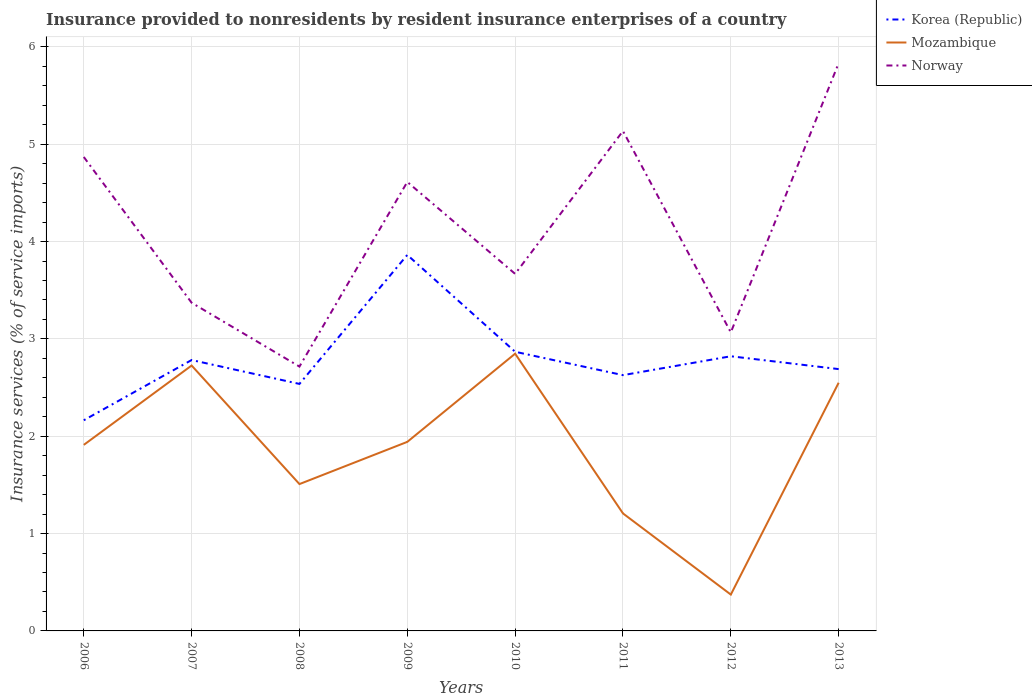How many different coloured lines are there?
Ensure brevity in your answer.  3. Is the number of lines equal to the number of legend labels?
Your response must be concise. Yes. Across all years, what is the maximum insurance provided to nonresidents in Norway?
Your answer should be compact. 2.72. In which year was the insurance provided to nonresidents in Mozambique maximum?
Offer a terse response. 2012. What is the total insurance provided to nonresidents in Mozambique in the graph?
Make the answer very short. -1.34. What is the difference between the highest and the second highest insurance provided to nonresidents in Norway?
Offer a very short reply. 3.12. What is the difference between the highest and the lowest insurance provided to nonresidents in Korea (Republic)?
Make the answer very short. 3. How many lines are there?
Offer a terse response. 3. How many years are there in the graph?
Make the answer very short. 8. What is the difference between two consecutive major ticks on the Y-axis?
Offer a terse response. 1. Does the graph contain grids?
Your answer should be compact. Yes. Where does the legend appear in the graph?
Offer a terse response. Top right. How many legend labels are there?
Your answer should be very brief. 3. How are the legend labels stacked?
Ensure brevity in your answer.  Vertical. What is the title of the graph?
Make the answer very short. Insurance provided to nonresidents by resident insurance enterprises of a country. What is the label or title of the X-axis?
Ensure brevity in your answer.  Years. What is the label or title of the Y-axis?
Offer a terse response. Insurance services (% of service imports). What is the Insurance services (% of service imports) in Korea (Republic) in 2006?
Provide a short and direct response. 2.16. What is the Insurance services (% of service imports) of Mozambique in 2006?
Keep it short and to the point. 1.91. What is the Insurance services (% of service imports) in Norway in 2006?
Offer a very short reply. 4.87. What is the Insurance services (% of service imports) in Korea (Republic) in 2007?
Provide a succinct answer. 2.78. What is the Insurance services (% of service imports) of Mozambique in 2007?
Ensure brevity in your answer.  2.73. What is the Insurance services (% of service imports) of Norway in 2007?
Keep it short and to the point. 3.37. What is the Insurance services (% of service imports) in Korea (Republic) in 2008?
Offer a very short reply. 2.54. What is the Insurance services (% of service imports) in Mozambique in 2008?
Offer a very short reply. 1.51. What is the Insurance services (% of service imports) of Norway in 2008?
Give a very brief answer. 2.72. What is the Insurance services (% of service imports) of Korea (Republic) in 2009?
Your answer should be very brief. 3.86. What is the Insurance services (% of service imports) of Mozambique in 2009?
Make the answer very short. 1.94. What is the Insurance services (% of service imports) of Norway in 2009?
Your response must be concise. 4.61. What is the Insurance services (% of service imports) of Korea (Republic) in 2010?
Your response must be concise. 2.87. What is the Insurance services (% of service imports) in Mozambique in 2010?
Provide a short and direct response. 2.85. What is the Insurance services (% of service imports) in Norway in 2010?
Give a very brief answer. 3.67. What is the Insurance services (% of service imports) of Korea (Republic) in 2011?
Make the answer very short. 2.63. What is the Insurance services (% of service imports) of Mozambique in 2011?
Provide a short and direct response. 1.21. What is the Insurance services (% of service imports) of Norway in 2011?
Provide a succinct answer. 5.14. What is the Insurance services (% of service imports) of Korea (Republic) in 2012?
Provide a short and direct response. 2.82. What is the Insurance services (% of service imports) in Mozambique in 2012?
Ensure brevity in your answer.  0.37. What is the Insurance services (% of service imports) of Norway in 2012?
Give a very brief answer. 3.07. What is the Insurance services (% of service imports) of Korea (Republic) in 2013?
Your answer should be compact. 2.69. What is the Insurance services (% of service imports) of Mozambique in 2013?
Give a very brief answer. 2.55. What is the Insurance services (% of service imports) in Norway in 2013?
Ensure brevity in your answer.  5.83. Across all years, what is the maximum Insurance services (% of service imports) of Korea (Republic)?
Your response must be concise. 3.86. Across all years, what is the maximum Insurance services (% of service imports) of Mozambique?
Offer a very short reply. 2.85. Across all years, what is the maximum Insurance services (% of service imports) in Norway?
Provide a short and direct response. 5.83. Across all years, what is the minimum Insurance services (% of service imports) in Korea (Republic)?
Ensure brevity in your answer.  2.16. Across all years, what is the minimum Insurance services (% of service imports) in Mozambique?
Provide a succinct answer. 0.37. Across all years, what is the minimum Insurance services (% of service imports) of Norway?
Offer a terse response. 2.72. What is the total Insurance services (% of service imports) of Korea (Republic) in the graph?
Keep it short and to the point. 22.35. What is the total Insurance services (% of service imports) in Mozambique in the graph?
Provide a succinct answer. 15.07. What is the total Insurance services (% of service imports) in Norway in the graph?
Your response must be concise. 33.27. What is the difference between the Insurance services (% of service imports) of Korea (Republic) in 2006 and that in 2007?
Your response must be concise. -0.62. What is the difference between the Insurance services (% of service imports) in Mozambique in 2006 and that in 2007?
Give a very brief answer. -0.82. What is the difference between the Insurance services (% of service imports) in Norway in 2006 and that in 2007?
Keep it short and to the point. 1.5. What is the difference between the Insurance services (% of service imports) in Korea (Republic) in 2006 and that in 2008?
Offer a very short reply. -0.37. What is the difference between the Insurance services (% of service imports) of Mozambique in 2006 and that in 2008?
Make the answer very short. 0.4. What is the difference between the Insurance services (% of service imports) of Norway in 2006 and that in 2008?
Give a very brief answer. 2.15. What is the difference between the Insurance services (% of service imports) of Korea (Republic) in 2006 and that in 2009?
Offer a terse response. -1.7. What is the difference between the Insurance services (% of service imports) in Mozambique in 2006 and that in 2009?
Offer a very short reply. -0.03. What is the difference between the Insurance services (% of service imports) of Norway in 2006 and that in 2009?
Your answer should be compact. 0.26. What is the difference between the Insurance services (% of service imports) in Korea (Republic) in 2006 and that in 2010?
Make the answer very short. -0.7. What is the difference between the Insurance services (% of service imports) in Mozambique in 2006 and that in 2010?
Offer a very short reply. -0.94. What is the difference between the Insurance services (% of service imports) of Norway in 2006 and that in 2010?
Keep it short and to the point. 1.2. What is the difference between the Insurance services (% of service imports) of Korea (Republic) in 2006 and that in 2011?
Your answer should be very brief. -0.46. What is the difference between the Insurance services (% of service imports) in Mozambique in 2006 and that in 2011?
Your response must be concise. 0.7. What is the difference between the Insurance services (% of service imports) of Norway in 2006 and that in 2011?
Your response must be concise. -0.27. What is the difference between the Insurance services (% of service imports) of Korea (Republic) in 2006 and that in 2012?
Your answer should be compact. -0.66. What is the difference between the Insurance services (% of service imports) in Mozambique in 2006 and that in 2012?
Provide a succinct answer. 1.54. What is the difference between the Insurance services (% of service imports) of Norway in 2006 and that in 2012?
Make the answer very short. 1.8. What is the difference between the Insurance services (% of service imports) in Korea (Republic) in 2006 and that in 2013?
Offer a terse response. -0.53. What is the difference between the Insurance services (% of service imports) in Mozambique in 2006 and that in 2013?
Your response must be concise. -0.64. What is the difference between the Insurance services (% of service imports) in Norway in 2006 and that in 2013?
Your answer should be compact. -0.96. What is the difference between the Insurance services (% of service imports) in Korea (Republic) in 2007 and that in 2008?
Offer a very short reply. 0.25. What is the difference between the Insurance services (% of service imports) of Mozambique in 2007 and that in 2008?
Your response must be concise. 1.22. What is the difference between the Insurance services (% of service imports) in Norway in 2007 and that in 2008?
Offer a terse response. 0.66. What is the difference between the Insurance services (% of service imports) in Korea (Republic) in 2007 and that in 2009?
Keep it short and to the point. -1.08. What is the difference between the Insurance services (% of service imports) in Mozambique in 2007 and that in 2009?
Keep it short and to the point. 0.78. What is the difference between the Insurance services (% of service imports) in Norway in 2007 and that in 2009?
Offer a terse response. -1.24. What is the difference between the Insurance services (% of service imports) in Korea (Republic) in 2007 and that in 2010?
Your answer should be compact. -0.09. What is the difference between the Insurance services (% of service imports) in Mozambique in 2007 and that in 2010?
Give a very brief answer. -0.12. What is the difference between the Insurance services (% of service imports) in Norway in 2007 and that in 2010?
Keep it short and to the point. -0.3. What is the difference between the Insurance services (% of service imports) of Korea (Republic) in 2007 and that in 2011?
Keep it short and to the point. 0.16. What is the difference between the Insurance services (% of service imports) of Mozambique in 2007 and that in 2011?
Keep it short and to the point. 1.52. What is the difference between the Insurance services (% of service imports) of Norway in 2007 and that in 2011?
Give a very brief answer. -1.76. What is the difference between the Insurance services (% of service imports) of Korea (Republic) in 2007 and that in 2012?
Ensure brevity in your answer.  -0.04. What is the difference between the Insurance services (% of service imports) of Mozambique in 2007 and that in 2012?
Offer a very short reply. 2.35. What is the difference between the Insurance services (% of service imports) in Norway in 2007 and that in 2012?
Make the answer very short. 0.3. What is the difference between the Insurance services (% of service imports) of Korea (Republic) in 2007 and that in 2013?
Keep it short and to the point. 0.09. What is the difference between the Insurance services (% of service imports) in Mozambique in 2007 and that in 2013?
Make the answer very short. 0.18. What is the difference between the Insurance services (% of service imports) in Norway in 2007 and that in 2013?
Your answer should be very brief. -2.46. What is the difference between the Insurance services (% of service imports) in Korea (Republic) in 2008 and that in 2009?
Offer a terse response. -1.33. What is the difference between the Insurance services (% of service imports) of Mozambique in 2008 and that in 2009?
Offer a very short reply. -0.43. What is the difference between the Insurance services (% of service imports) of Norway in 2008 and that in 2009?
Provide a succinct answer. -1.9. What is the difference between the Insurance services (% of service imports) in Korea (Republic) in 2008 and that in 2010?
Ensure brevity in your answer.  -0.33. What is the difference between the Insurance services (% of service imports) of Mozambique in 2008 and that in 2010?
Provide a short and direct response. -1.34. What is the difference between the Insurance services (% of service imports) in Norway in 2008 and that in 2010?
Offer a terse response. -0.95. What is the difference between the Insurance services (% of service imports) in Korea (Republic) in 2008 and that in 2011?
Ensure brevity in your answer.  -0.09. What is the difference between the Insurance services (% of service imports) in Mozambique in 2008 and that in 2011?
Offer a very short reply. 0.3. What is the difference between the Insurance services (% of service imports) of Norway in 2008 and that in 2011?
Your response must be concise. -2.42. What is the difference between the Insurance services (% of service imports) in Korea (Republic) in 2008 and that in 2012?
Your answer should be very brief. -0.28. What is the difference between the Insurance services (% of service imports) in Mozambique in 2008 and that in 2012?
Offer a very short reply. 1.14. What is the difference between the Insurance services (% of service imports) in Norway in 2008 and that in 2012?
Your answer should be compact. -0.35. What is the difference between the Insurance services (% of service imports) of Korea (Republic) in 2008 and that in 2013?
Provide a succinct answer. -0.15. What is the difference between the Insurance services (% of service imports) of Mozambique in 2008 and that in 2013?
Make the answer very short. -1.04. What is the difference between the Insurance services (% of service imports) in Norway in 2008 and that in 2013?
Your answer should be compact. -3.12. What is the difference between the Insurance services (% of service imports) in Mozambique in 2009 and that in 2010?
Give a very brief answer. -0.91. What is the difference between the Insurance services (% of service imports) of Norway in 2009 and that in 2010?
Offer a terse response. 0.94. What is the difference between the Insurance services (% of service imports) in Korea (Republic) in 2009 and that in 2011?
Make the answer very short. 1.24. What is the difference between the Insurance services (% of service imports) in Mozambique in 2009 and that in 2011?
Ensure brevity in your answer.  0.74. What is the difference between the Insurance services (% of service imports) in Norway in 2009 and that in 2011?
Provide a succinct answer. -0.52. What is the difference between the Insurance services (% of service imports) of Korea (Republic) in 2009 and that in 2012?
Ensure brevity in your answer.  1.04. What is the difference between the Insurance services (% of service imports) in Mozambique in 2009 and that in 2012?
Give a very brief answer. 1.57. What is the difference between the Insurance services (% of service imports) in Norway in 2009 and that in 2012?
Provide a succinct answer. 1.55. What is the difference between the Insurance services (% of service imports) of Korea (Republic) in 2009 and that in 2013?
Keep it short and to the point. 1.17. What is the difference between the Insurance services (% of service imports) in Mozambique in 2009 and that in 2013?
Provide a short and direct response. -0.61. What is the difference between the Insurance services (% of service imports) in Norway in 2009 and that in 2013?
Ensure brevity in your answer.  -1.22. What is the difference between the Insurance services (% of service imports) in Korea (Republic) in 2010 and that in 2011?
Provide a succinct answer. 0.24. What is the difference between the Insurance services (% of service imports) of Mozambique in 2010 and that in 2011?
Offer a terse response. 1.64. What is the difference between the Insurance services (% of service imports) of Norway in 2010 and that in 2011?
Offer a terse response. -1.47. What is the difference between the Insurance services (% of service imports) of Korea (Republic) in 2010 and that in 2012?
Keep it short and to the point. 0.05. What is the difference between the Insurance services (% of service imports) in Mozambique in 2010 and that in 2012?
Keep it short and to the point. 2.47. What is the difference between the Insurance services (% of service imports) of Norway in 2010 and that in 2012?
Your answer should be compact. 0.6. What is the difference between the Insurance services (% of service imports) of Korea (Republic) in 2010 and that in 2013?
Provide a succinct answer. 0.18. What is the difference between the Insurance services (% of service imports) of Mozambique in 2010 and that in 2013?
Keep it short and to the point. 0.3. What is the difference between the Insurance services (% of service imports) of Norway in 2010 and that in 2013?
Provide a short and direct response. -2.16. What is the difference between the Insurance services (% of service imports) of Korea (Republic) in 2011 and that in 2012?
Your answer should be very brief. -0.19. What is the difference between the Insurance services (% of service imports) of Mozambique in 2011 and that in 2012?
Your response must be concise. 0.83. What is the difference between the Insurance services (% of service imports) in Norway in 2011 and that in 2012?
Provide a succinct answer. 2.07. What is the difference between the Insurance services (% of service imports) in Korea (Republic) in 2011 and that in 2013?
Your answer should be very brief. -0.06. What is the difference between the Insurance services (% of service imports) in Mozambique in 2011 and that in 2013?
Offer a very short reply. -1.34. What is the difference between the Insurance services (% of service imports) in Norway in 2011 and that in 2013?
Offer a very short reply. -0.7. What is the difference between the Insurance services (% of service imports) in Korea (Republic) in 2012 and that in 2013?
Provide a succinct answer. 0.13. What is the difference between the Insurance services (% of service imports) of Mozambique in 2012 and that in 2013?
Ensure brevity in your answer.  -2.18. What is the difference between the Insurance services (% of service imports) in Norway in 2012 and that in 2013?
Make the answer very short. -2.77. What is the difference between the Insurance services (% of service imports) in Korea (Republic) in 2006 and the Insurance services (% of service imports) in Mozambique in 2007?
Offer a very short reply. -0.56. What is the difference between the Insurance services (% of service imports) in Korea (Republic) in 2006 and the Insurance services (% of service imports) in Norway in 2007?
Make the answer very short. -1.21. What is the difference between the Insurance services (% of service imports) of Mozambique in 2006 and the Insurance services (% of service imports) of Norway in 2007?
Ensure brevity in your answer.  -1.46. What is the difference between the Insurance services (% of service imports) of Korea (Republic) in 2006 and the Insurance services (% of service imports) of Mozambique in 2008?
Give a very brief answer. 0.66. What is the difference between the Insurance services (% of service imports) of Korea (Republic) in 2006 and the Insurance services (% of service imports) of Norway in 2008?
Provide a short and direct response. -0.55. What is the difference between the Insurance services (% of service imports) of Mozambique in 2006 and the Insurance services (% of service imports) of Norway in 2008?
Keep it short and to the point. -0.8. What is the difference between the Insurance services (% of service imports) in Korea (Republic) in 2006 and the Insurance services (% of service imports) in Mozambique in 2009?
Your answer should be compact. 0.22. What is the difference between the Insurance services (% of service imports) of Korea (Republic) in 2006 and the Insurance services (% of service imports) of Norway in 2009?
Your answer should be compact. -2.45. What is the difference between the Insurance services (% of service imports) in Mozambique in 2006 and the Insurance services (% of service imports) in Norway in 2009?
Keep it short and to the point. -2.7. What is the difference between the Insurance services (% of service imports) of Korea (Republic) in 2006 and the Insurance services (% of service imports) of Mozambique in 2010?
Your answer should be compact. -0.68. What is the difference between the Insurance services (% of service imports) of Korea (Republic) in 2006 and the Insurance services (% of service imports) of Norway in 2010?
Your answer should be compact. -1.5. What is the difference between the Insurance services (% of service imports) in Mozambique in 2006 and the Insurance services (% of service imports) in Norway in 2010?
Your answer should be compact. -1.76. What is the difference between the Insurance services (% of service imports) in Korea (Republic) in 2006 and the Insurance services (% of service imports) in Norway in 2011?
Offer a terse response. -2.97. What is the difference between the Insurance services (% of service imports) of Mozambique in 2006 and the Insurance services (% of service imports) of Norway in 2011?
Offer a terse response. -3.22. What is the difference between the Insurance services (% of service imports) in Korea (Republic) in 2006 and the Insurance services (% of service imports) in Mozambique in 2012?
Provide a succinct answer. 1.79. What is the difference between the Insurance services (% of service imports) of Korea (Republic) in 2006 and the Insurance services (% of service imports) of Norway in 2012?
Your answer should be very brief. -0.9. What is the difference between the Insurance services (% of service imports) in Mozambique in 2006 and the Insurance services (% of service imports) in Norway in 2012?
Offer a terse response. -1.16. What is the difference between the Insurance services (% of service imports) in Korea (Republic) in 2006 and the Insurance services (% of service imports) in Mozambique in 2013?
Keep it short and to the point. -0.39. What is the difference between the Insurance services (% of service imports) of Korea (Republic) in 2006 and the Insurance services (% of service imports) of Norway in 2013?
Give a very brief answer. -3.67. What is the difference between the Insurance services (% of service imports) in Mozambique in 2006 and the Insurance services (% of service imports) in Norway in 2013?
Your answer should be compact. -3.92. What is the difference between the Insurance services (% of service imports) in Korea (Republic) in 2007 and the Insurance services (% of service imports) in Mozambique in 2008?
Your answer should be very brief. 1.27. What is the difference between the Insurance services (% of service imports) in Korea (Republic) in 2007 and the Insurance services (% of service imports) in Norway in 2008?
Provide a succinct answer. 0.07. What is the difference between the Insurance services (% of service imports) of Mozambique in 2007 and the Insurance services (% of service imports) of Norway in 2008?
Offer a terse response. 0.01. What is the difference between the Insurance services (% of service imports) in Korea (Republic) in 2007 and the Insurance services (% of service imports) in Mozambique in 2009?
Give a very brief answer. 0.84. What is the difference between the Insurance services (% of service imports) of Korea (Republic) in 2007 and the Insurance services (% of service imports) of Norway in 2009?
Ensure brevity in your answer.  -1.83. What is the difference between the Insurance services (% of service imports) of Mozambique in 2007 and the Insurance services (% of service imports) of Norway in 2009?
Your response must be concise. -1.89. What is the difference between the Insurance services (% of service imports) of Korea (Republic) in 2007 and the Insurance services (% of service imports) of Mozambique in 2010?
Ensure brevity in your answer.  -0.07. What is the difference between the Insurance services (% of service imports) in Korea (Republic) in 2007 and the Insurance services (% of service imports) in Norway in 2010?
Your answer should be compact. -0.89. What is the difference between the Insurance services (% of service imports) in Mozambique in 2007 and the Insurance services (% of service imports) in Norway in 2010?
Provide a succinct answer. -0.94. What is the difference between the Insurance services (% of service imports) of Korea (Republic) in 2007 and the Insurance services (% of service imports) of Mozambique in 2011?
Provide a short and direct response. 1.58. What is the difference between the Insurance services (% of service imports) of Korea (Republic) in 2007 and the Insurance services (% of service imports) of Norway in 2011?
Provide a succinct answer. -2.35. What is the difference between the Insurance services (% of service imports) of Mozambique in 2007 and the Insurance services (% of service imports) of Norway in 2011?
Offer a very short reply. -2.41. What is the difference between the Insurance services (% of service imports) of Korea (Republic) in 2007 and the Insurance services (% of service imports) of Mozambique in 2012?
Give a very brief answer. 2.41. What is the difference between the Insurance services (% of service imports) of Korea (Republic) in 2007 and the Insurance services (% of service imports) of Norway in 2012?
Your answer should be compact. -0.28. What is the difference between the Insurance services (% of service imports) in Mozambique in 2007 and the Insurance services (% of service imports) in Norway in 2012?
Make the answer very short. -0.34. What is the difference between the Insurance services (% of service imports) of Korea (Republic) in 2007 and the Insurance services (% of service imports) of Mozambique in 2013?
Offer a very short reply. 0.23. What is the difference between the Insurance services (% of service imports) in Korea (Republic) in 2007 and the Insurance services (% of service imports) in Norway in 2013?
Provide a short and direct response. -3.05. What is the difference between the Insurance services (% of service imports) of Mozambique in 2007 and the Insurance services (% of service imports) of Norway in 2013?
Ensure brevity in your answer.  -3.11. What is the difference between the Insurance services (% of service imports) of Korea (Republic) in 2008 and the Insurance services (% of service imports) of Mozambique in 2009?
Provide a short and direct response. 0.6. What is the difference between the Insurance services (% of service imports) in Korea (Republic) in 2008 and the Insurance services (% of service imports) in Norway in 2009?
Provide a short and direct response. -2.07. What is the difference between the Insurance services (% of service imports) of Mozambique in 2008 and the Insurance services (% of service imports) of Norway in 2009?
Your answer should be compact. -3.1. What is the difference between the Insurance services (% of service imports) in Korea (Republic) in 2008 and the Insurance services (% of service imports) in Mozambique in 2010?
Give a very brief answer. -0.31. What is the difference between the Insurance services (% of service imports) in Korea (Republic) in 2008 and the Insurance services (% of service imports) in Norway in 2010?
Provide a short and direct response. -1.13. What is the difference between the Insurance services (% of service imports) of Mozambique in 2008 and the Insurance services (% of service imports) of Norway in 2010?
Give a very brief answer. -2.16. What is the difference between the Insurance services (% of service imports) in Korea (Republic) in 2008 and the Insurance services (% of service imports) in Mozambique in 2011?
Provide a short and direct response. 1.33. What is the difference between the Insurance services (% of service imports) of Korea (Republic) in 2008 and the Insurance services (% of service imports) of Norway in 2011?
Offer a very short reply. -2.6. What is the difference between the Insurance services (% of service imports) in Mozambique in 2008 and the Insurance services (% of service imports) in Norway in 2011?
Your answer should be compact. -3.63. What is the difference between the Insurance services (% of service imports) in Korea (Republic) in 2008 and the Insurance services (% of service imports) in Mozambique in 2012?
Keep it short and to the point. 2.16. What is the difference between the Insurance services (% of service imports) of Korea (Republic) in 2008 and the Insurance services (% of service imports) of Norway in 2012?
Give a very brief answer. -0.53. What is the difference between the Insurance services (% of service imports) of Mozambique in 2008 and the Insurance services (% of service imports) of Norway in 2012?
Give a very brief answer. -1.56. What is the difference between the Insurance services (% of service imports) in Korea (Republic) in 2008 and the Insurance services (% of service imports) in Mozambique in 2013?
Offer a terse response. -0.01. What is the difference between the Insurance services (% of service imports) in Korea (Republic) in 2008 and the Insurance services (% of service imports) in Norway in 2013?
Give a very brief answer. -3.3. What is the difference between the Insurance services (% of service imports) in Mozambique in 2008 and the Insurance services (% of service imports) in Norway in 2013?
Provide a short and direct response. -4.32. What is the difference between the Insurance services (% of service imports) in Korea (Republic) in 2009 and the Insurance services (% of service imports) in Mozambique in 2010?
Make the answer very short. 1.01. What is the difference between the Insurance services (% of service imports) in Korea (Republic) in 2009 and the Insurance services (% of service imports) in Norway in 2010?
Your response must be concise. 0.19. What is the difference between the Insurance services (% of service imports) of Mozambique in 2009 and the Insurance services (% of service imports) of Norway in 2010?
Keep it short and to the point. -1.73. What is the difference between the Insurance services (% of service imports) in Korea (Republic) in 2009 and the Insurance services (% of service imports) in Mozambique in 2011?
Offer a very short reply. 2.66. What is the difference between the Insurance services (% of service imports) in Korea (Republic) in 2009 and the Insurance services (% of service imports) in Norway in 2011?
Provide a succinct answer. -1.27. What is the difference between the Insurance services (% of service imports) of Mozambique in 2009 and the Insurance services (% of service imports) of Norway in 2011?
Offer a terse response. -3.19. What is the difference between the Insurance services (% of service imports) in Korea (Republic) in 2009 and the Insurance services (% of service imports) in Mozambique in 2012?
Your answer should be compact. 3.49. What is the difference between the Insurance services (% of service imports) of Korea (Republic) in 2009 and the Insurance services (% of service imports) of Norway in 2012?
Make the answer very short. 0.8. What is the difference between the Insurance services (% of service imports) in Mozambique in 2009 and the Insurance services (% of service imports) in Norway in 2012?
Offer a very short reply. -1.12. What is the difference between the Insurance services (% of service imports) of Korea (Republic) in 2009 and the Insurance services (% of service imports) of Mozambique in 2013?
Offer a very short reply. 1.31. What is the difference between the Insurance services (% of service imports) in Korea (Republic) in 2009 and the Insurance services (% of service imports) in Norway in 2013?
Make the answer very short. -1.97. What is the difference between the Insurance services (% of service imports) of Mozambique in 2009 and the Insurance services (% of service imports) of Norway in 2013?
Ensure brevity in your answer.  -3.89. What is the difference between the Insurance services (% of service imports) in Korea (Republic) in 2010 and the Insurance services (% of service imports) in Mozambique in 2011?
Provide a succinct answer. 1.66. What is the difference between the Insurance services (% of service imports) of Korea (Republic) in 2010 and the Insurance services (% of service imports) of Norway in 2011?
Keep it short and to the point. -2.27. What is the difference between the Insurance services (% of service imports) in Mozambique in 2010 and the Insurance services (% of service imports) in Norway in 2011?
Make the answer very short. -2.29. What is the difference between the Insurance services (% of service imports) in Korea (Republic) in 2010 and the Insurance services (% of service imports) in Mozambique in 2012?
Offer a very short reply. 2.49. What is the difference between the Insurance services (% of service imports) of Korea (Republic) in 2010 and the Insurance services (% of service imports) of Norway in 2012?
Offer a terse response. -0.2. What is the difference between the Insurance services (% of service imports) of Mozambique in 2010 and the Insurance services (% of service imports) of Norway in 2012?
Make the answer very short. -0.22. What is the difference between the Insurance services (% of service imports) in Korea (Republic) in 2010 and the Insurance services (% of service imports) in Mozambique in 2013?
Offer a very short reply. 0.32. What is the difference between the Insurance services (% of service imports) of Korea (Republic) in 2010 and the Insurance services (% of service imports) of Norway in 2013?
Your answer should be very brief. -2.96. What is the difference between the Insurance services (% of service imports) of Mozambique in 2010 and the Insurance services (% of service imports) of Norway in 2013?
Your answer should be compact. -2.98. What is the difference between the Insurance services (% of service imports) of Korea (Republic) in 2011 and the Insurance services (% of service imports) of Mozambique in 2012?
Keep it short and to the point. 2.25. What is the difference between the Insurance services (% of service imports) in Korea (Republic) in 2011 and the Insurance services (% of service imports) in Norway in 2012?
Provide a short and direct response. -0.44. What is the difference between the Insurance services (% of service imports) of Mozambique in 2011 and the Insurance services (% of service imports) of Norway in 2012?
Your response must be concise. -1.86. What is the difference between the Insurance services (% of service imports) of Korea (Republic) in 2011 and the Insurance services (% of service imports) of Mozambique in 2013?
Your answer should be very brief. 0.08. What is the difference between the Insurance services (% of service imports) in Korea (Republic) in 2011 and the Insurance services (% of service imports) in Norway in 2013?
Offer a terse response. -3.21. What is the difference between the Insurance services (% of service imports) of Mozambique in 2011 and the Insurance services (% of service imports) of Norway in 2013?
Your answer should be very brief. -4.63. What is the difference between the Insurance services (% of service imports) in Korea (Republic) in 2012 and the Insurance services (% of service imports) in Mozambique in 2013?
Offer a terse response. 0.27. What is the difference between the Insurance services (% of service imports) in Korea (Republic) in 2012 and the Insurance services (% of service imports) in Norway in 2013?
Keep it short and to the point. -3.01. What is the difference between the Insurance services (% of service imports) of Mozambique in 2012 and the Insurance services (% of service imports) of Norway in 2013?
Your answer should be compact. -5.46. What is the average Insurance services (% of service imports) in Korea (Republic) per year?
Provide a short and direct response. 2.79. What is the average Insurance services (% of service imports) in Mozambique per year?
Offer a very short reply. 1.88. What is the average Insurance services (% of service imports) in Norway per year?
Keep it short and to the point. 4.16. In the year 2006, what is the difference between the Insurance services (% of service imports) of Korea (Republic) and Insurance services (% of service imports) of Mozambique?
Provide a short and direct response. 0.25. In the year 2006, what is the difference between the Insurance services (% of service imports) in Korea (Republic) and Insurance services (% of service imports) in Norway?
Offer a very short reply. -2.7. In the year 2006, what is the difference between the Insurance services (% of service imports) of Mozambique and Insurance services (% of service imports) of Norway?
Offer a very short reply. -2.96. In the year 2007, what is the difference between the Insurance services (% of service imports) in Korea (Republic) and Insurance services (% of service imports) in Mozambique?
Provide a succinct answer. 0.06. In the year 2007, what is the difference between the Insurance services (% of service imports) of Korea (Republic) and Insurance services (% of service imports) of Norway?
Give a very brief answer. -0.59. In the year 2007, what is the difference between the Insurance services (% of service imports) in Mozambique and Insurance services (% of service imports) in Norway?
Ensure brevity in your answer.  -0.64. In the year 2008, what is the difference between the Insurance services (% of service imports) of Korea (Republic) and Insurance services (% of service imports) of Mozambique?
Provide a short and direct response. 1.03. In the year 2008, what is the difference between the Insurance services (% of service imports) of Korea (Republic) and Insurance services (% of service imports) of Norway?
Provide a succinct answer. -0.18. In the year 2008, what is the difference between the Insurance services (% of service imports) of Mozambique and Insurance services (% of service imports) of Norway?
Give a very brief answer. -1.21. In the year 2009, what is the difference between the Insurance services (% of service imports) in Korea (Republic) and Insurance services (% of service imports) in Mozambique?
Offer a very short reply. 1.92. In the year 2009, what is the difference between the Insurance services (% of service imports) in Korea (Republic) and Insurance services (% of service imports) in Norway?
Your response must be concise. -0.75. In the year 2009, what is the difference between the Insurance services (% of service imports) in Mozambique and Insurance services (% of service imports) in Norway?
Offer a very short reply. -2.67. In the year 2010, what is the difference between the Insurance services (% of service imports) of Korea (Republic) and Insurance services (% of service imports) of Mozambique?
Provide a short and direct response. 0.02. In the year 2010, what is the difference between the Insurance services (% of service imports) of Korea (Republic) and Insurance services (% of service imports) of Norway?
Your answer should be very brief. -0.8. In the year 2010, what is the difference between the Insurance services (% of service imports) of Mozambique and Insurance services (% of service imports) of Norway?
Make the answer very short. -0.82. In the year 2011, what is the difference between the Insurance services (% of service imports) in Korea (Republic) and Insurance services (% of service imports) in Mozambique?
Provide a short and direct response. 1.42. In the year 2011, what is the difference between the Insurance services (% of service imports) of Korea (Republic) and Insurance services (% of service imports) of Norway?
Your answer should be very brief. -2.51. In the year 2011, what is the difference between the Insurance services (% of service imports) of Mozambique and Insurance services (% of service imports) of Norway?
Provide a succinct answer. -3.93. In the year 2012, what is the difference between the Insurance services (% of service imports) of Korea (Republic) and Insurance services (% of service imports) of Mozambique?
Keep it short and to the point. 2.45. In the year 2012, what is the difference between the Insurance services (% of service imports) in Korea (Republic) and Insurance services (% of service imports) in Norway?
Your answer should be compact. -0.25. In the year 2012, what is the difference between the Insurance services (% of service imports) of Mozambique and Insurance services (% of service imports) of Norway?
Make the answer very short. -2.69. In the year 2013, what is the difference between the Insurance services (% of service imports) of Korea (Republic) and Insurance services (% of service imports) of Mozambique?
Provide a short and direct response. 0.14. In the year 2013, what is the difference between the Insurance services (% of service imports) in Korea (Republic) and Insurance services (% of service imports) in Norway?
Provide a succinct answer. -3.14. In the year 2013, what is the difference between the Insurance services (% of service imports) of Mozambique and Insurance services (% of service imports) of Norway?
Offer a very short reply. -3.28. What is the ratio of the Insurance services (% of service imports) of Korea (Republic) in 2006 to that in 2007?
Provide a short and direct response. 0.78. What is the ratio of the Insurance services (% of service imports) in Mozambique in 2006 to that in 2007?
Give a very brief answer. 0.7. What is the ratio of the Insurance services (% of service imports) in Norway in 2006 to that in 2007?
Offer a terse response. 1.44. What is the ratio of the Insurance services (% of service imports) of Korea (Republic) in 2006 to that in 2008?
Your answer should be compact. 0.85. What is the ratio of the Insurance services (% of service imports) of Mozambique in 2006 to that in 2008?
Provide a short and direct response. 1.27. What is the ratio of the Insurance services (% of service imports) in Norway in 2006 to that in 2008?
Your response must be concise. 1.79. What is the ratio of the Insurance services (% of service imports) in Korea (Republic) in 2006 to that in 2009?
Your response must be concise. 0.56. What is the ratio of the Insurance services (% of service imports) of Norway in 2006 to that in 2009?
Provide a short and direct response. 1.06. What is the ratio of the Insurance services (% of service imports) of Korea (Republic) in 2006 to that in 2010?
Make the answer very short. 0.75. What is the ratio of the Insurance services (% of service imports) of Mozambique in 2006 to that in 2010?
Offer a very short reply. 0.67. What is the ratio of the Insurance services (% of service imports) in Norway in 2006 to that in 2010?
Your response must be concise. 1.33. What is the ratio of the Insurance services (% of service imports) in Korea (Republic) in 2006 to that in 2011?
Offer a terse response. 0.82. What is the ratio of the Insurance services (% of service imports) of Mozambique in 2006 to that in 2011?
Make the answer very short. 1.58. What is the ratio of the Insurance services (% of service imports) of Norway in 2006 to that in 2011?
Your response must be concise. 0.95. What is the ratio of the Insurance services (% of service imports) in Korea (Republic) in 2006 to that in 2012?
Your response must be concise. 0.77. What is the ratio of the Insurance services (% of service imports) in Mozambique in 2006 to that in 2012?
Your response must be concise. 5.12. What is the ratio of the Insurance services (% of service imports) of Norway in 2006 to that in 2012?
Your answer should be compact. 1.59. What is the ratio of the Insurance services (% of service imports) in Korea (Republic) in 2006 to that in 2013?
Give a very brief answer. 0.8. What is the ratio of the Insurance services (% of service imports) of Mozambique in 2006 to that in 2013?
Provide a succinct answer. 0.75. What is the ratio of the Insurance services (% of service imports) in Norway in 2006 to that in 2013?
Give a very brief answer. 0.83. What is the ratio of the Insurance services (% of service imports) in Korea (Republic) in 2007 to that in 2008?
Provide a succinct answer. 1.1. What is the ratio of the Insurance services (% of service imports) in Mozambique in 2007 to that in 2008?
Your answer should be compact. 1.81. What is the ratio of the Insurance services (% of service imports) of Norway in 2007 to that in 2008?
Your response must be concise. 1.24. What is the ratio of the Insurance services (% of service imports) of Korea (Republic) in 2007 to that in 2009?
Offer a terse response. 0.72. What is the ratio of the Insurance services (% of service imports) in Mozambique in 2007 to that in 2009?
Give a very brief answer. 1.4. What is the ratio of the Insurance services (% of service imports) of Norway in 2007 to that in 2009?
Your answer should be very brief. 0.73. What is the ratio of the Insurance services (% of service imports) in Korea (Republic) in 2007 to that in 2010?
Keep it short and to the point. 0.97. What is the ratio of the Insurance services (% of service imports) of Mozambique in 2007 to that in 2010?
Your answer should be very brief. 0.96. What is the ratio of the Insurance services (% of service imports) of Norway in 2007 to that in 2010?
Ensure brevity in your answer.  0.92. What is the ratio of the Insurance services (% of service imports) in Korea (Republic) in 2007 to that in 2011?
Give a very brief answer. 1.06. What is the ratio of the Insurance services (% of service imports) of Mozambique in 2007 to that in 2011?
Make the answer very short. 2.26. What is the ratio of the Insurance services (% of service imports) of Norway in 2007 to that in 2011?
Your answer should be compact. 0.66. What is the ratio of the Insurance services (% of service imports) in Korea (Republic) in 2007 to that in 2012?
Provide a short and direct response. 0.99. What is the ratio of the Insurance services (% of service imports) of Mozambique in 2007 to that in 2012?
Your response must be concise. 7.3. What is the ratio of the Insurance services (% of service imports) of Norway in 2007 to that in 2012?
Your answer should be very brief. 1.1. What is the ratio of the Insurance services (% of service imports) of Korea (Republic) in 2007 to that in 2013?
Provide a short and direct response. 1.03. What is the ratio of the Insurance services (% of service imports) in Mozambique in 2007 to that in 2013?
Keep it short and to the point. 1.07. What is the ratio of the Insurance services (% of service imports) of Norway in 2007 to that in 2013?
Your answer should be very brief. 0.58. What is the ratio of the Insurance services (% of service imports) of Korea (Republic) in 2008 to that in 2009?
Your answer should be compact. 0.66. What is the ratio of the Insurance services (% of service imports) of Mozambique in 2008 to that in 2009?
Keep it short and to the point. 0.78. What is the ratio of the Insurance services (% of service imports) in Norway in 2008 to that in 2009?
Keep it short and to the point. 0.59. What is the ratio of the Insurance services (% of service imports) of Korea (Republic) in 2008 to that in 2010?
Offer a terse response. 0.88. What is the ratio of the Insurance services (% of service imports) in Mozambique in 2008 to that in 2010?
Make the answer very short. 0.53. What is the ratio of the Insurance services (% of service imports) of Norway in 2008 to that in 2010?
Your response must be concise. 0.74. What is the ratio of the Insurance services (% of service imports) of Korea (Republic) in 2008 to that in 2011?
Give a very brief answer. 0.97. What is the ratio of the Insurance services (% of service imports) of Mozambique in 2008 to that in 2011?
Ensure brevity in your answer.  1.25. What is the ratio of the Insurance services (% of service imports) of Norway in 2008 to that in 2011?
Provide a succinct answer. 0.53. What is the ratio of the Insurance services (% of service imports) in Korea (Republic) in 2008 to that in 2012?
Ensure brevity in your answer.  0.9. What is the ratio of the Insurance services (% of service imports) in Mozambique in 2008 to that in 2012?
Provide a succinct answer. 4.04. What is the ratio of the Insurance services (% of service imports) of Norway in 2008 to that in 2012?
Ensure brevity in your answer.  0.89. What is the ratio of the Insurance services (% of service imports) of Korea (Republic) in 2008 to that in 2013?
Provide a short and direct response. 0.94. What is the ratio of the Insurance services (% of service imports) of Mozambique in 2008 to that in 2013?
Make the answer very short. 0.59. What is the ratio of the Insurance services (% of service imports) in Norway in 2008 to that in 2013?
Your response must be concise. 0.47. What is the ratio of the Insurance services (% of service imports) in Korea (Republic) in 2009 to that in 2010?
Make the answer very short. 1.35. What is the ratio of the Insurance services (% of service imports) in Mozambique in 2009 to that in 2010?
Ensure brevity in your answer.  0.68. What is the ratio of the Insurance services (% of service imports) in Norway in 2009 to that in 2010?
Provide a short and direct response. 1.26. What is the ratio of the Insurance services (% of service imports) in Korea (Republic) in 2009 to that in 2011?
Your answer should be very brief. 1.47. What is the ratio of the Insurance services (% of service imports) of Mozambique in 2009 to that in 2011?
Make the answer very short. 1.61. What is the ratio of the Insurance services (% of service imports) of Norway in 2009 to that in 2011?
Keep it short and to the point. 0.9. What is the ratio of the Insurance services (% of service imports) in Korea (Republic) in 2009 to that in 2012?
Your answer should be very brief. 1.37. What is the ratio of the Insurance services (% of service imports) of Mozambique in 2009 to that in 2012?
Offer a terse response. 5.2. What is the ratio of the Insurance services (% of service imports) in Norway in 2009 to that in 2012?
Your answer should be very brief. 1.5. What is the ratio of the Insurance services (% of service imports) in Korea (Republic) in 2009 to that in 2013?
Offer a very short reply. 1.44. What is the ratio of the Insurance services (% of service imports) in Mozambique in 2009 to that in 2013?
Provide a short and direct response. 0.76. What is the ratio of the Insurance services (% of service imports) of Norway in 2009 to that in 2013?
Provide a short and direct response. 0.79. What is the ratio of the Insurance services (% of service imports) in Korea (Republic) in 2010 to that in 2011?
Your response must be concise. 1.09. What is the ratio of the Insurance services (% of service imports) of Mozambique in 2010 to that in 2011?
Offer a terse response. 2.36. What is the ratio of the Insurance services (% of service imports) of Korea (Republic) in 2010 to that in 2012?
Provide a succinct answer. 1.02. What is the ratio of the Insurance services (% of service imports) in Mozambique in 2010 to that in 2012?
Offer a very short reply. 7.63. What is the ratio of the Insurance services (% of service imports) of Norway in 2010 to that in 2012?
Keep it short and to the point. 1.2. What is the ratio of the Insurance services (% of service imports) of Korea (Republic) in 2010 to that in 2013?
Offer a very short reply. 1.07. What is the ratio of the Insurance services (% of service imports) in Mozambique in 2010 to that in 2013?
Make the answer very short. 1.12. What is the ratio of the Insurance services (% of service imports) of Norway in 2010 to that in 2013?
Offer a terse response. 0.63. What is the ratio of the Insurance services (% of service imports) of Korea (Republic) in 2011 to that in 2012?
Your response must be concise. 0.93. What is the ratio of the Insurance services (% of service imports) of Mozambique in 2011 to that in 2012?
Provide a succinct answer. 3.23. What is the ratio of the Insurance services (% of service imports) of Norway in 2011 to that in 2012?
Your response must be concise. 1.67. What is the ratio of the Insurance services (% of service imports) of Korea (Republic) in 2011 to that in 2013?
Your answer should be compact. 0.98. What is the ratio of the Insurance services (% of service imports) in Mozambique in 2011 to that in 2013?
Provide a succinct answer. 0.47. What is the ratio of the Insurance services (% of service imports) in Norway in 2011 to that in 2013?
Provide a succinct answer. 0.88. What is the ratio of the Insurance services (% of service imports) of Korea (Republic) in 2012 to that in 2013?
Offer a very short reply. 1.05. What is the ratio of the Insurance services (% of service imports) of Mozambique in 2012 to that in 2013?
Keep it short and to the point. 0.15. What is the ratio of the Insurance services (% of service imports) of Norway in 2012 to that in 2013?
Give a very brief answer. 0.53. What is the difference between the highest and the second highest Insurance services (% of service imports) of Mozambique?
Offer a very short reply. 0.12. What is the difference between the highest and the second highest Insurance services (% of service imports) in Norway?
Provide a short and direct response. 0.7. What is the difference between the highest and the lowest Insurance services (% of service imports) of Korea (Republic)?
Ensure brevity in your answer.  1.7. What is the difference between the highest and the lowest Insurance services (% of service imports) of Mozambique?
Offer a very short reply. 2.47. What is the difference between the highest and the lowest Insurance services (% of service imports) of Norway?
Your answer should be very brief. 3.12. 